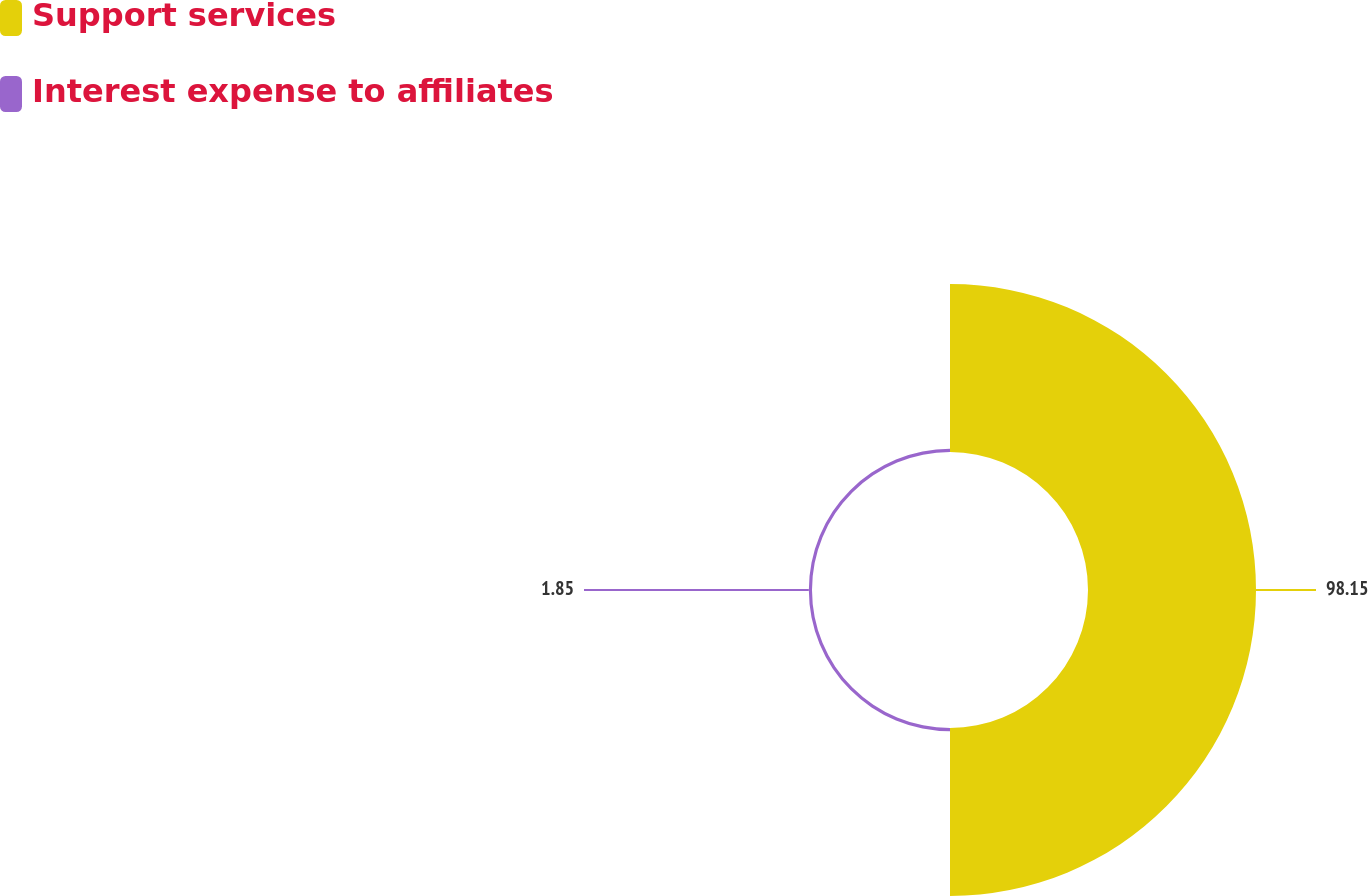Convert chart to OTSL. <chart><loc_0><loc_0><loc_500><loc_500><pie_chart><fcel>Support services<fcel>Interest expense to affiliates<nl><fcel>98.15%<fcel>1.85%<nl></chart> 